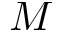<formula> <loc_0><loc_0><loc_500><loc_500>M</formula> 